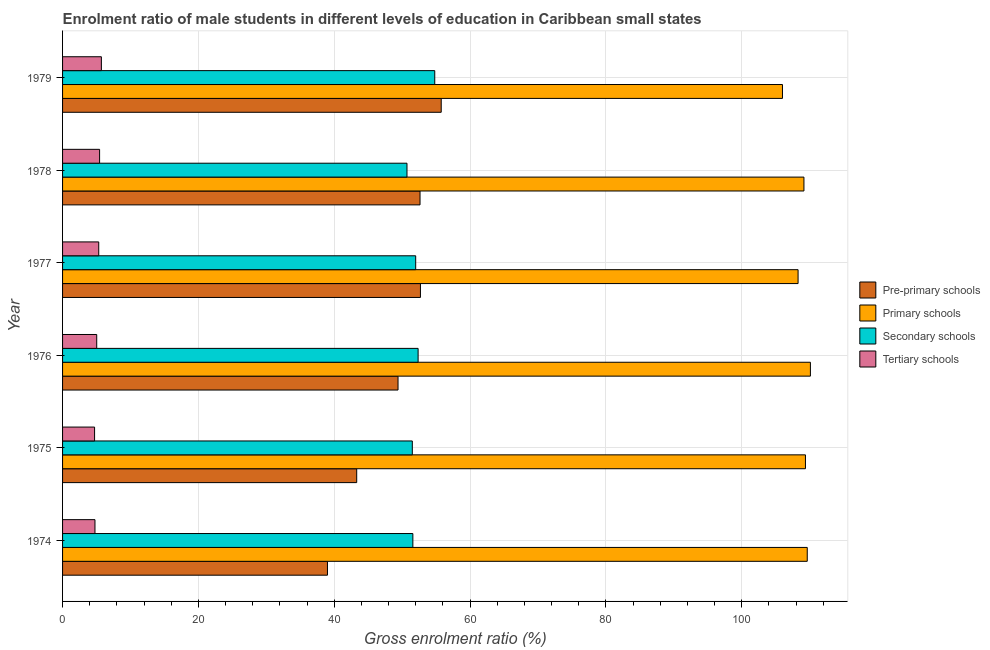What is the label of the 2nd group of bars from the top?
Your answer should be very brief. 1978. What is the gross enrolment ratio(female) in pre-primary schools in 1976?
Ensure brevity in your answer.  49.4. Across all years, what is the maximum gross enrolment ratio(female) in pre-primary schools?
Your answer should be very brief. 55.76. Across all years, what is the minimum gross enrolment ratio(female) in secondary schools?
Offer a terse response. 50.72. In which year was the gross enrolment ratio(female) in tertiary schools maximum?
Give a very brief answer. 1979. In which year was the gross enrolment ratio(female) in pre-primary schools minimum?
Provide a succinct answer. 1974. What is the total gross enrolment ratio(female) in primary schools in the graph?
Make the answer very short. 652.65. What is the difference between the gross enrolment ratio(female) in tertiary schools in 1975 and that in 1979?
Keep it short and to the point. -1. What is the difference between the gross enrolment ratio(female) in secondary schools in 1978 and the gross enrolment ratio(female) in pre-primary schools in 1976?
Your answer should be very brief. 1.32. What is the average gross enrolment ratio(female) in primary schools per year?
Provide a short and direct response. 108.78. In the year 1977, what is the difference between the gross enrolment ratio(female) in pre-primary schools and gross enrolment ratio(female) in primary schools?
Make the answer very short. -55.61. What is the ratio of the gross enrolment ratio(female) in tertiary schools in 1976 to that in 1979?
Provide a short and direct response. 0.88. What is the difference between the highest and the second highest gross enrolment ratio(female) in primary schools?
Your answer should be compact. 0.47. What is the difference between the highest and the lowest gross enrolment ratio(female) in primary schools?
Provide a succinct answer. 4.12. Is the sum of the gross enrolment ratio(female) in primary schools in 1976 and 1978 greater than the maximum gross enrolment ratio(female) in pre-primary schools across all years?
Offer a very short reply. Yes. Is it the case that in every year, the sum of the gross enrolment ratio(female) in tertiary schools and gross enrolment ratio(female) in secondary schools is greater than the sum of gross enrolment ratio(female) in pre-primary schools and gross enrolment ratio(female) in primary schools?
Provide a short and direct response. No. What does the 4th bar from the top in 1974 represents?
Make the answer very short. Pre-primary schools. What does the 2nd bar from the bottom in 1977 represents?
Your response must be concise. Primary schools. Is it the case that in every year, the sum of the gross enrolment ratio(female) in pre-primary schools and gross enrolment ratio(female) in primary schools is greater than the gross enrolment ratio(female) in secondary schools?
Give a very brief answer. Yes. Are all the bars in the graph horizontal?
Make the answer very short. Yes. How many years are there in the graph?
Offer a terse response. 6. What is the difference between two consecutive major ticks on the X-axis?
Offer a terse response. 20. Does the graph contain any zero values?
Make the answer very short. No. Does the graph contain grids?
Provide a short and direct response. Yes. Where does the legend appear in the graph?
Offer a very short reply. Center right. How are the legend labels stacked?
Your answer should be compact. Vertical. What is the title of the graph?
Keep it short and to the point. Enrolment ratio of male students in different levels of education in Caribbean small states. Does "Burnt food" appear as one of the legend labels in the graph?
Make the answer very short. No. What is the label or title of the Y-axis?
Your answer should be very brief. Year. What is the Gross enrolment ratio (%) in Pre-primary schools in 1974?
Your answer should be compact. 39.01. What is the Gross enrolment ratio (%) in Primary schools in 1974?
Provide a short and direct response. 109.66. What is the Gross enrolment ratio (%) of Secondary schools in 1974?
Give a very brief answer. 51.58. What is the Gross enrolment ratio (%) in Tertiary schools in 1974?
Offer a terse response. 4.77. What is the Gross enrolment ratio (%) of Pre-primary schools in 1975?
Give a very brief answer. 43.31. What is the Gross enrolment ratio (%) in Primary schools in 1975?
Provide a short and direct response. 109.39. What is the Gross enrolment ratio (%) in Secondary schools in 1975?
Your answer should be compact. 51.5. What is the Gross enrolment ratio (%) in Tertiary schools in 1975?
Provide a succinct answer. 4.71. What is the Gross enrolment ratio (%) of Pre-primary schools in 1976?
Ensure brevity in your answer.  49.4. What is the Gross enrolment ratio (%) of Primary schools in 1976?
Give a very brief answer. 110.12. What is the Gross enrolment ratio (%) of Secondary schools in 1976?
Your answer should be very brief. 52.35. What is the Gross enrolment ratio (%) of Tertiary schools in 1976?
Offer a very short reply. 5.03. What is the Gross enrolment ratio (%) of Pre-primary schools in 1977?
Offer a very short reply. 52.7. What is the Gross enrolment ratio (%) of Primary schools in 1977?
Ensure brevity in your answer.  108.31. What is the Gross enrolment ratio (%) of Secondary schools in 1977?
Your response must be concise. 52. What is the Gross enrolment ratio (%) in Tertiary schools in 1977?
Offer a terse response. 5.33. What is the Gross enrolment ratio (%) in Pre-primary schools in 1978?
Give a very brief answer. 52.64. What is the Gross enrolment ratio (%) of Primary schools in 1978?
Provide a short and direct response. 109.17. What is the Gross enrolment ratio (%) in Secondary schools in 1978?
Give a very brief answer. 50.72. What is the Gross enrolment ratio (%) of Tertiary schools in 1978?
Make the answer very short. 5.45. What is the Gross enrolment ratio (%) in Pre-primary schools in 1979?
Keep it short and to the point. 55.76. What is the Gross enrolment ratio (%) of Primary schools in 1979?
Offer a very short reply. 106.01. What is the Gross enrolment ratio (%) in Secondary schools in 1979?
Ensure brevity in your answer.  54.81. What is the Gross enrolment ratio (%) in Tertiary schools in 1979?
Offer a terse response. 5.71. Across all years, what is the maximum Gross enrolment ratio (%) in Pre-primary schools?
Offer a very short reply. 55.76. Across all years, what is the maximum Gross enrolment ratio (%) in Primary schools?
Your response must be concise. 110.12. Across all years, what is the maximum Gross enrolment ratio (%) in Secondary schools?
Your answer should be very brief. 54.81. Across all years, what is the maximum Gross enrolment ratio (%) in Tertiary schools?
Give a very brief answer. 5.71. Across all years, what is the minimum Gross enrolment ratio (%) in Pre-primary schools?
Provide a short and direct response. 39.01. Across all years, what is the minimum Gross enrolment ratio (%) in Primary schools?
Your response must be concise. 106.01. Across all years, what is the minimum Gross enrolment ratio (%) of Secondary schools?
Give a very brief answer. 50.72. Across all years, what is the minimum Gross enrolment ratio (%) of Tertiary schools?
Ensure brevity in your answer.  4.71. What is the total Gross enrolment ratio (%) of Pre-primary schools in the graph?
Provide a short and direct response. 292.81. What is the total Gross enrolment ratio (%) of Primary schools in the graph?
Give a very brief answer. 652.65. What is the total Gross enrolment ratio (%) in Secondary schools in the graph?
Give a very brief answer. 312.95. What is the total Gross enrolment ratio (%) in Tertiary schools in the graph?
Give a very brief answer. 31.01. What is the difference between the Gross enrolment ratio (%) of Pre-primary schools in 1974 and that in 1975?
Make the answer very short. -4.3. What is the difference between the Gross enrolment ratio (%) of Primary schools in 1974 and that in 1975?
Offer a very short reply. 0.27. What is the difference between the Gross enrolment ratio (%) of Tertiary schools in 1974 and that in 1975?
Provide a succinct answer. 0.06. What is the difference between the Gross enrolment ratio (%) of Pre-primary schools in 1974 and that in 1976?
Offer a terse response. -10.39. What is the difference between the Gross enrolment ratio (%) in Primary schools in 1974 and that in 1976?
Provide a short and direct response. -0.47. What is the difference between the Gross enrolment ratio (%) of Secondary schools in 1974 and that in 1976?
Keep it short and to the point. -0.77. What is the difference between the Gross enrolment ratio (%) of Tertiary schools in 1974 and that in 1976?
Your response must be concise. -0.26. What is the difference between the Gross enrolment ratio (%) of Pre-primary schools in 1974 and that in 1977?
Provide a succinct answer. -13.69. What is the difference between the Gross enrolment ratio (%) of Primary schools in 1974 and that in 1977?
Provide a short and direct response. 1.35. What is the difference between the Gross enrolment ratio (%) in Secondary schools in 1974 and that in 1977?
Your answer should be compact. -0.42. What is the difference between the Gross enrolment ratio (%) in Tertiary schools in 1974 and that in 1977?
Provide a short and direct response. -0.55. What is the difference between the Gross enrolment ratio (%) of Pre-primary schools in 1974 and that in 1978?
Keep it short and to the point. -13.63. What is the difference between the Gross enrolment ratio (%) in Primary schools in 1974 and that in 1978?
Your answer should be very brief. 0.49. What is the difference between the Gross enrolment ratio (%) of Secondary schools in 1974 and that in 1978?
Give a very brief answer. 0.86. What is the difference between the Gross enrolment ratio (%) in Tertiary schools in 1974 and that in 1978?
Make the answer very short. -0.68. What is the difference between the Gross enrolment ratio (%) in Pre-primary schools in 1974 and that in 1979?
Give a very brief answer. -16.75. What is the difference between the Gross enrolment ratio (%) of Primary schools in 1974 and that in 1979?
Your answer should be very brief. 3.65. What is the difference between the Gross enrolment ratio (%) of Secondary schools in 1974 and that in 1979?
Keep it short and to the point. -3.23. What is the difference between the Gross enrolment ratio (%) of Tertiary schools in 1974 and that in 1979?
Give a very brief answer. -0.94. What is the difference between the Gross enrolment ratio (%) in Pre-primary schools in 1975 and that in 1976?
Provide a short and direct response. -6.09. What is the difference between the Gross enrolment ratio (%) in Primary schools in 1975 and that in 1976?
Offer a terse response. -0.73. What is the difference between the Gross enrolment ratio (%) of Secondary schools in 1975 and that in 1976?
Provide a short and direct response. -0.85. What is the difference between the Gross enrolment ratio (%) of Tertiary schools in 1975 and that in 1976?
Offer a very short reply. -0.31. What is the difference between the Gross enrolment ratio (%) of Pre-primary schools in 1975 and that in 1977?
Offer a terse response. -9.38. What is the difference between the Gross enrolment ratio (%) in Primary schools in 1975 and that in 1977?
Your answer should be very brief. 1.08. What is the difference between the Gross enrolment ratio (%) of Secondary schools in 1975 and that in 1977?
Your answer should be compact. -0.5. What is the difference between the Gross enrolment ratio (%) in Tertiary schools in 1975 and that in 1977?
Keep it short and to the point. -0.61. What is the difference between the Gross enrolment ratio (%) in Pre-primary schools in 1975 and that in 1978?
Offer a very short reply. -9.33. What is the difference between the Gross enrolment ratio (%) in Primary schools in 1975 and that in 1978?
Keep it short and to the point. 0.22. What is the difference between the Gross enrolment ratio (%) in Secondary schools in 1975 and that in 1978?
Offer a very short reply. 0.78. What is the difference between the Gross enrolment ratio (%) in Tertiary schools in 1975 and that in 1978?
Provide a short and direct response. -0.74. What is the difference between the Gross enrolment ratio (%) in Pre-primary schools in 1975 and that in 1979?
Provide a succinct answer. -12.44. What is the difference between the Gross enrolment ratio (%) of Primary schools in 1975 and that in 1979?
Your answer should be very brief. 3.38. What is the difference between the Gross enrolment ratio (%) in Secondary schools in 1975 and that in 1979?
Your answer should be very brief. -3.31. What is the difference between the Gross enrolment ratio (%) in Tertiary schools in 1975 and that in 1979?
Provide a succinct answer. -1. What is the difference between the Gross enrolment ratio (%) in Pre-primary schools in 1976 and that in 1977?
Provide a short and direct response. -3.3. What is the difference between the Gross enrolment ratio (%) of Primary schools in 1976 and that in 1977?
Keep it short and to the point. 1.82. What is the difference between the Gross enrolment ratio (%) of Secondary schools in 1976 and that in 1977?
Provide a succinct answer. 0.36. What is the difference between the Gross enrolment ratio (%) of Tertiary schools in 1976 and that in 1977?
Provide a short and direct response. -0.3. What is the difference between the Gross enrolment ratio (%) in Pre-primary schools in 1976 and that in 1978?
Your answer should be compact. -3.24. What is the difference between the Gross enrolment ratio (%) of Primary schools in 1976 and that in 1978?
Your answer should be very brief. 0.95. What is the difference between the Gross enrolment ratio (%) in Secondary schools in 1976 and that in 1978?
Your answer should be very brief. 1.64. What is the difference between the Gross enrolment ratio (%) in Tertiary schools in 1976 and that in 1978?
Keep it short and to the point. -0.42. What is the difference between the Gross enrolment ratio (%) in Pre-primary schools in 1976 and that in 1979?
Offer a terse response. -6.36. What is the difference between the Gross enrolment ratio (%) in Primary schools in 1976 and that in 1979?
Offer a very short reply. 4.12. What is the difference between the Gross enrolment ratio (%) of Secondary schools in 1976 and that in 1979?
Provide a succinct answer. -2.45. What is the difference between the Gross enrolment ratio (%) of Tertiary schools in 1976 and that in 1979?
Make the answer very short. -0.69. What is the difference between the Gross enrolment ratio (%) of Pre-primary schools in 1977 and that in 1978?
Your answer should be very brief. 0.06. What is the difference between the Gross enrolment ratio (%) of Primary schools in 1977 and that in 1978?
Offer a very short reply. -0.86. What is the difference between the Gross enrolment ratio (%) in Secondary schools in 1977 and that in 1978?
Keep it short and to the point. 1.28. What is the difference between the Gross enrolment ratio (%) in Tertiary schools in 1977 and that in 1978?
Ensure brevity in your answer.  -0.13. What is the difference between the Gross enrolment ratio (%) in Pre-primary schools in 1977 and that in 1979?
Offer a very short reply. -3.06. What is the difference between the Gross enrolment ratio (%) of Primary schools in 1977 and that in 1979?
Give a very brief answer. 2.3. What is the difference between the Gross enrolment ratio (%) in Secondary schools in 1977 and that in 1979?
Offer a very short reply. -2.81. What is the difference between the Gross enrolment ratio (%) of Tertiary schools in 1977 and that in 1979?
Provide a succinct answer. -0.39. What is the difference between the Gross enrolment ratio (%) in Pre-primary schools in 1978 and that in 1979?
Give a very brief answer. -3.12. What is the difference between the Gross enrolment ratio (%) in Primary schools in 1978 and that in 1979?
Keep it short and to the point. 3.16. What is the difference between the Gross enrolment ratio (%) in Secondary schools in 1978 and that in 1979?
Your answer should be very brief. -4.09. What is the difference between the Gross enrolment ratio (%) in Tertiary schools in 1978 and that in 1979?
Provide a succinct answer. -0.26. What is the difference between the Gross enrolment ratio (%) in Pre-primary schools in 1974 and the Gross enrolment ratio (%) in Primary schools in 1975?
Provide a succinct answer. -70.38. What is the difference between the Gross enrolment ratio (%) in Pre-primary schools in 1974 and the Gross enrolment ratio (%) in Secondary schools in 1975?
Make the answer very short. -12.49. What is the difference between the Gross enrolment ratio (%) in Pre-primary schools in 1974 and the Gross enrolment ratio (%) in Tertiary schools in 1975?
Make the answer very short. 34.29. What is the difference between the Gross enrolment ratio (%) of Primary schools in 1974 and the Gross enrolment ratio (%) of Secondary schools in 1975?
Your answer should be compact. 58.16. What is the difference between the Gross enrolment ratio (%) of Primary schools in 1974 and the Gross enrolment ratio (%) of Tertiary schools in 1975?
Provide a succinct answer. 104.94. What is the difference between the Gross enrolment ratio (%) of Secondary schools in 1974 and the Gross enrolment ratio (%) of Tertiary schools in 1975?
Provide a short and direct response. 46.87. What is the difference between the Gross enrolment ratio (%) in Pre-primary schools in 1974 and the Gross enrolment ratio (%) in Primary schools in 1976?
Make the answer very short. -71.11. What is the difference between the Gross enrolment ratio (%) in Pre-primary schools in 1974 and the Gross enrolment ratio (%) in Secondary schools in 1976?
Provide a succinct answer. -13.35. What is the difference between the Gross enrolment ratio (%) in Pre-primary schools in 1974 and the Gross enrolment ratio (%) in Tertiary schools in 1976?
Give a very brief answer. 33.98. What is the difference between the Gross enrolment ratio (%) of Primary schools in 1974 and the Gross enrolment ratio (%) of Secondary schools in 1976?
Provide a succinct answer. 57.3. What is the difference between the Gross enrolment ratio (%) in Primary schools in 1974 and the Gross enrolment ratio (%) in Tertiary schools in 1976?
Ensure brevity in your answer.  104.63. What is the difference between the Gross enrolment ratio (%) in Secondary schools in 1974 and the Gross enrolment ratio (%) in Tertiary schools in 1976?
Provide a succinct answer. 46.55. What is the difference between the Gross enrolment ratio (%) of Pre-primary schools in 1974 and the Gross enrolment ratio (%) of Primary schools in 1977?
Your answer should be compact. -69.3. What is the difference between the Gross enrolment ratio (%) in Pre-primary schools in 1974 and the Gross enrolment ratio (%) in Secondary schools in 1977?
Provide a succinct answer. -12.99. What is the difference between the Gross enrolment ratio (%) of Pre-primary schools in 1974 and the Gross enrolment ratio (%) of Tertiary schools in 1977?
Your response must be concise. 33.68. What is the difference between the Gross enrolment ratio (%) of Primary schools in 1974 and the Gross enrolment ratio (%) of Secondary schools in 1977?
Make the answer very short. 57.66. What is the difference between the Gross enrolment ratio (%) in Primary schools in 1974 and the Gross enrolment ratio (%) in Tertiary schools in 1977?
Provide a short and direct response. 104.33. What is the difference between the Gross enrolment ratio (%) of Secondary schools in 1974 and the Gross enrolment ratio (%) of Tertiary schools in 1977?
Give a very brief answer. 46.25. What is the difference between the Gross enrolment ratio (%) in Pre-primary schools in 1974 and the Gross enrolment ratio (%) in Primary schools in 1978?
Your answer should be compact. -70.16. What is the difference between the Gross enrolment ratio (%) of Pre-primary schools in 1974 and the Gross enrolment ratio (%) of Secondary schools in 1978?
Provide a succinct answer. -11.71. What is the difference between the Gross enrolment ratio (%) of Pre-primary schools in 1974 and the Gross enrolment ratio (%) of Tertiary schools in 1978?
Your response must be concise. 33.55. What is the difference between the Gross enrolment ratio (%) of Primary schools in 1974 and the Gross enrolment ratio (%) of Secondary schools in 1978?
Ensure brevity in your answer.  58.94. What is the difference between the Gross enrolment ratio (%) in Primary schools in 1974 and the Gross enrolment ratio (%) in Tertiary schools in 1978?
Your answer should be very brief. 104.2. What is the difference between the Gross enrolment ratio (%) in Secondary schools in 1974 and the Gross enrolment ratio (%) in Tertiary schools in 1978?
Provide a succinct answer. 46.13. What is the difference between the Gross enrolment ratio (%) of Pre-primary schools in 1974 and the Gross enrolment ratio (%) of Primary schools in 1979?
Offer a very short reply. -67. What is the difference between the Gross enrolment ratio (%) in Pre-primary schools in 1974 and the Gross enrolment ratio (%) in Secondary schools in 1979?
Keep it short and to the point. -15.8. What is the difference between the Gross enrolment ratio (%) in Pre-primary schools in 1974 and the Gross enrolment ratio (%) in Tertiary schools in 1979?
Make the answer very short. 33.29. What is the difference between the Gross enrolment ratio (%) in Primary schools in 1974 and the Gross enrolment ratio (%) in Secondary schools in 1979?
Your response must be concise. 54.85. What is the difference between the Gross enrolment ratio (%) in Primary schools in 1974 and the Gross enrolment ratio (%) in Tertiary schools in 1979?
Make the answer very short. 103.94. What is the difference between the Gross enrolment ratio (%) of Secondary schools in 1974 and the Gross enrolment ratio (%) of Tertiary schools in 1979?
Offer a terse response. 45.87. What is the difference between the Gross enrolment ratio (%) in Pre-primary schools in 1975 and the Gross enrolment ratio (%) in Primary schools in 1976?
Ensure brevity in your answer.  -66.81. What is the difference between the Gross enrolment ratio (%) of Pre-primary schools in 1975 and the Gross enrolment ratio (%) of Secondary schools in 1976?
Give a very brief answer. -9.04. What is the difference between the Gross enrolment ratio (%) of Pre-primary schools in 1975 and the Gross enrolment ratio (%) of Tertiary schools in 1976?
Provide a short and direct response. 38.28. What is the difference between the Gross enrolment ratio (%) of Primary schools in 1975 and the Gross enrolment ratio (%) of Secondary schools in 1976?
Offer a very short reply. 57.04. What is the difference between the Gross enrolment ratio (%) of Primary schools in 1975 and the Gross enrolment ratio (%) of Tertiary schools in 1976?
Make the answer very short. 104.36. What is the difference between the Gross enrolment ratio (%) in Secondary schools in 1975 and the Gross enrolment ratio (%) in Tertiary schools in 1976?
Provide a short and direct response. 46.47. What is the difference between the Gross enrolment ratio (%) in Pre-primary schools in 1975 and the Gross enrolment ratio (%) in Primary schools in 1977?
Make the answer very short. -64.99. What is the difference between the Gross enrolment ratio (%) in Pre-primary schools in 1975 and the Gross enrolment ratio (%) in Secondary schools in 1977?
Offer a terse response. -8.69. What is the difference between the Gross enrolment ratio (%) in Pre-primary schools in 1975 and the Gross enrolment ratio (%) in Tertiary schools in 1977?
Make the answer very short. 37.99. What is the difference between the Gross enrolment ratio (%) in Primary schools in 1975 and the Gross enrolment ratio (%) in Secondary schools in 1977?
Provide a succinct answer. 57.39. What is the difference between the Gross enrolment ratio (%) in Primary schools in 1975 and the Gross enrolment ratio (%) in Tertiary schools in 1977?
Keep it short and to the point. 104.06. What is the difference between the Gross enrolment ratio (%) in Secondary schools in 1975 and the Gross enrolment ratio (%) in Tertiary schools in 1977?
Provide a short and direct response. 46.17. What is the difference between the Gross enrolment ratio (%) of Pre-primary schools in 1975 and the Gross enrolment ratio (%) of Primary schools in 1978?
Your answer should be compact. -65.86. What is the difference between the Gross enrolment ratio (%) of Pre-primary schools in 1975 and the Gross enrolment ratio (%) of Secondary schools in 1978?
Your answer should be very brief. -7.4. What is the difference between the Gross enrolment ratio (%) of Pre-primary schools in 1975 and the Gross enrolment ratio (%) of Tertiary schools in 1978?
Give a very brief answer. 37.86. What is the difference between the Gross enrolment ratio (%) of Primary schools in 1975 and the Gross enrolment ratio (%) of Secondary schools in 1978?
Offer a terse response. 58.68. What is the difference between the Gross enrolment ratio (%) in Primary schools in 1975 and the Gross enrolment ratio (%) in Tertiary schools in 1978?
Provide a short and direct response. 103.94. What is the difference between the Gross enrolment ratio (%) of Secondary schools in 1975 and the Gross enrolment ratio (%) of Tertiary schools in 1978?
Offer a terse response. 46.05. What is the difference between the Gross enrolment ratio (%) in Pre-primary schools in 1975 and the Gross enrolment ratio (%) in Primary schools in 1979?
Your answer should be very brief. -62.69. What is the difference between the Gross enrolment ratio (%) in Pre-primary schools in 1975 and the Gross enrolment ratio (%) in Secondary schools in 1979?
Provide a succinct answer. -11.49. What is the difference between the Gross enrolment ratio (%) in Pre-primary schools in 1975 and the Gross enrolment ratio (%) in Tertiary schools in 1979?
Provide a succinct answer. 37.6. What is the difference between the Gross enrolment ratio (%) in Primary schools in 1975 and the Gross enrolment ratio (%) in Secondary schools in 1979?
Keep it short and to the point. 54.59. What is the difference between the Gross enrolment ratio (%) in Primary schools in 1975 and the Gross enrolment ratio (%) in Tertiary schools in 1979?
Offer a very short reply. 103.68. What is the difference between the Gross enrolment ratio (%) in Secondary schools in 1975 and the Gross enrolment ratio (%) in Tertiary schools in 1979?
Offer a terse response. 45.79. What is the difference between the Gross enrolment ratio (%) of Pre-primary schools in 1976 and the Gross enrolment ratio (%) of Primary schools in 1977?
Provide a succinct answer. -58.91. What is the difference between the Gross enrolment ratio (%) in Pre-primary schools in 1976 and the Gross enrolment ratio (%) in Secondary schools in 1977?
Offer a very short reply. -2.6. What is the difference between the Gross enrolment ratio (%) in Pre-primary schools in 1976 and the Gross enrolment ratio (%) in Tertiary schools in 1977?
Keep it short and to the point. 44.07. What is the difference between the Gross enrolment ratio (%) in Primary schools in 1976 and the Gross enrolment ratio (%) in Secondary schools in 1977?
Your response must be concise. 58.12. What is the difference between the Gross enrolment ratio (%) of Primary schools in 1976 and the Gross enrolment ratio (%) of Tertiary schools in 1977?
Ensure brevity in your answer.  104.8. What is the difference between the Gross enrolment ratio (%) in Secondary schools in 1976 and the Gross enrolment ratio (%) in Tertiary schools in 1977?
Offer a terse response. 47.03. What is the difference between the Gross enrolment ratio (%) of Pre-primary schools in 1976 and the Gross enrolment ratio (%) of Primary schools in 1978?
Offer a very short reply. -59.77. What is the difference between the Gross enrolment ratio (%) of Pre-primary schools in 1976 and the Gross enrolment ratio (%) of Secondary schools in 1978?
Offer a very short reply. -1.32. What is the difference between the Gross enrolment ratio (%) in Pre-primary schools in 1976 and the Gross enrolment ratio (%) in Tertiary schools in 1978?
Keep it short and to the point. 43.94. What is the difference between the Gross enrolment ratio (%) of Primary schools in 1976 and the Gross enrolment ratio (%) of Secondary schools in 1978?
Your response must be concise. 59.41. What is the difference between the Gross enrolment ratio (%) of Primary schools in 1976 and the Gross enrolment ratio (%) of Tertiary schools in 1978?
Ensure brevity in your answer.  104.67. What is the difference between the Gross enrolment ratio (%) in Secondary schools in 1976 and the Gross enrolment ratio (%) in Tertiary schools in 1978?
Your response must be concise. 46.9. What is the difference between the Gross enrolment ratio (%) of Pre-primary schools in 1976 and the Gross enrolment ratio (%) of Primary schools in 1979?
Provide a succinct answer. -56.61. What is the difference between the Gross enrolment ratio (%) of Pre-primary schools in 1976 and the Gross enrolment ratio (%) of Secondary schools in 1979?
Ensure brevity in your answer.  -5.41. What is the difference between the Gross enrolment ratio (%) of Pre-primary schools in 1976 and the Gross enrolment ratio (%) of Tertiary schools in 1979?
Your answer should be very brief. 43.68. What is the difference between the Gross enrolment ratio (%) in Primary schools in 1976 and the Gross enrolment ratio (%) in Secondary schools in 1979?
Make the answer very short. 55.32. What is the difference between the Gross enrolment ratio (%) of Primary schools in 1976 and the Gross enrolment ratio (%) of Tertiary schools in 1979?
Your answer should be compact. 104.41. What is the difference between the Gross enrolment ratio (%) of Secondary schools in 1976 and the Gross enrolment ratio (%) of Tertiary schools in 1979?
Provide a succinct answer. 46.64. What is the difference between the Gross enrolment ratio (%) of Pre-primary schools in 1977 and the Gross enrolment ratio (%) of Primary schools in 1978?
Your answer should be very brief. -56.47. What is the difference between the Gross enrolment ratio (%) of Pre-primary schools in 1977 and the Gross enrolment ratio (%) of Secondary schools in 1978?
Make the answer very short. 1.98. What is the difference between the Gross enrolment ratio (%) in Pre-primary schools in 1977 and the Gross enrolment ratio (%) in Tertiary schools in 1978?
Offer a terse response. 47.24. What is the difference between the Gross enrolment ratio (%) of Primary schools in 1977 and the Gross enrolment ratio (%) of Secondary schools in 1978?
Give a very brief answer. 57.59. What is the difference between the Gross enrolment ratio (%) of Primary schools in 1977 and the Gross enrolment ratio (%) of Tertiary schools in 1978?
Offer a very short reply. 102.85. What is the difference between the Gross enrolment ratio (%) of Secondary schools in 1977 and the Gross enrolment ratio (%) of Tertiary schools in 1978?
Your answer should be very brief. 46.54. What is the difference between the Gross enrolment ratio (%) in Pre-primary schools in 1977 and the Gross enrolment ratio (%) in Primary schools in 1979?
Provide a succinct answer. -53.31. What is the difference between the Gross enrolment ratio (%) in Pre-primary schools in 1977 and the Gross enrolment ratio (%) in Secondary schools in 1979?
Your answer should be very brief. -2.11. What is the difference between the Gross enrolment ratio (%) of Pre-primary schools in 1977 and the Gross enrolment ratio (%) of Tertiary schools in 1979?
Your response must be concise. 46.98. What is the difference between the Gross enrolment ratio (%) in Primary schools in 1977 and the Gross enrolment ratio (%) in Secondary schools in 1979?
Provide a succinct answer. 53.5. What is the difference between the Gross enrolment ratio (%) of Primary schools in 1977 and the Gross enrolment ratio (%) of Tertiary schools in 1979?
Provide a succinct answer. 102.59. What is the difference between the Gross enrolment ratio (%) of Secondary schools in 1977 and the Gross enrolment ratio (%) of Tertiary schools in 1979?
Provide a succinct answer. 46.28. What is the difference between the Gross enrolment ratio (%) in Pre-primary schools in 1978 and the Gross enrolment ratio (%) in Primary schools in 1979?
Your response must be concise. -53.37. What is the difference between the Gross enrolment ratio (%) of Pre-primary schools in 1978 and the Gross enrolment ratio (%) of Secondary schools in 1979?
Your answer should be very brief. -2.17. What is the difference between the Gross enrolment ratio (%) of Pre-primary schools in 1978 and the Gross enrolment ratio (%) of Tertiary schools in 1979?
Give a very brief answer. 46.92. What is the difference between the Gross enrolment ratio (%) in Primary schools in 1978 and the Gross enrolment ratio (%) in Secondary schools in 1979?
Offer a terse response. 54.36. What is the difference between the Gross enrolment ratio (%) in Primary schools in 1978 and the Gross enrolment ratio (%) in Tertiary schools in 1979?
Your answer should be very brief. 103.46. What is the difference between the Gross enrolment ratio (%) in Secondary schools in 1978 and the Gross enrolment ratio (%) in Tertiary schools in 1979?
Offer a very short reply. 45. What is the average Gross enrolment ratio (%) of Pre-primary schools per year?
Give a very brief answer. 48.8. What is the average Gross enrolment ratio (%) in Primary schools per year?
Make the answer very short. 108.78. What is the average Gross enrolment ratio (%) in Secondary schools per year?
Your answer should be very brief. 52.16. What is the average Gross enrolment ratio (%) of Tertiary schools per year?
Provide a succinct answer. 5.17. In the year 1974, what is the difference between the Gross enrolment ratio (%) of Pre-primary schools and Gross enrolment ratio (%) of Primary schools?
Your response must be concise. -70.65. In the year 1974, what is the difference between the Gross enrolment ratio (%) in Pre-primary schools and Gross enrolment ratio (%) in Secondary schools?
Provide a succinct answer. -12.57. In the year 1974, what is the difference between the Gross enrolment ratio (%) in Pre-primary schools and Gross enrolment ratio (%) in Tertiary schools?
Your response must be concise. 34.24. In the year 1974, what is the difference between the Gross enrolment ratio (%) in Primary schools and Gross enrolment ratio (%) in Secondary schools?
Provide a short and direct response. 58.08. In the year 1974, what is the difference between the Gross enrolment ratio (%) of Primary schools and Gross enrolment ratio (%) of Tertiary schools?
Make the answer very short. 104.88. In the year 1974, what is the difference between the Gross enrolment ratio (%) of Secondary schools and Gross enrolment ratio (%) of Tertiary schools?
Ensure brevity in your answer.  46.81. In the year 1975, what is the difference between the Gross enrolment ratio (%) of Pre-primary schools and Gross enrolment ratio (%) of Primary schools?
Offer a very short reply. -66.08. In the year 1975, what is the difference between the Gross enrolment ratio (%) in Pre-primary schools and Gross enrolment ratio (%) in Secondary schools?
Keep it short and to the point. -8.19. In the year 1975, what is the difference between the Gross enrolment ratio (%) in Pre-primary schools and Gross enrolment ratio (%) in Tertiary schools?
Your answer should be very brief. 38.6. In the year 1975, what is the difference between the Gross enrolment ratio (%) of Primary schools and Gross enrolment ratio (%) of Secondary schools?
Make the answer very short. 57.89. In the year 1975, what is the difference between the Gross enrolment ratio (%) of Primary schools and Gross enrolment ratio (%) of Tertiary schools?
Your answer should be compact. 104.68. In the year 1975, what is the difference between the Gross enrolment ratio (%) in Secondary schools and Gross enrolment ratio (%) in Tertiary schools?
Your answer should be compact. 46.79. In the year 1976, what is the difference between the Gross enrolment ratio (%) of Pre-primary schools and Gross enrolment ratio (%) of Primary schools?
Give a very brief answer. -60.72. In the year 1976, what is the difference between the Gross enrolment ratio (%) in Pre-primary schools and Gross enrolment ratio (%) in Secondary schools?
Provide a succinct answer. -2.96. In the year 1976, what is the difference between the Gross enrolment ratio (%) in Pre-primary schools and Gross enrolment ratio (%) in Tertiary schools?
Your answer should be very brief. 44.37. In the year 1976, what is the difference between the Gross enrolment ratio (%) in Primary schools and Gross enrolment ratio (%) in Secondary schools?
Your response must be concise. 57.77. In the year 1976, what is the difference between the Gross enrolment ratio (%) of Primary schools and Gross enrolment ratio (%) of Tertiary schools?
Offer a very short reply. 105.09. In the year 1976, what is the difference between the Gross enrolment ratio (%) of Secondary schools and Gross enrolment ratio (%) of Tertiary schools?
Provide a succinct answer. 47.33. In the year 1977, what is the difference between the Gross enrolment ratio (%) in Pre-primary schools and Gross enrolment ratio (%) in Primary schools?
Provide a succinct answer. -55.61. In the year 1977, what is the difference between the Gross enrolment ratio (%) of Pre-primary schools and Gross enrolment ratio (%) of Secondary schools?
Your answer should be compact. 0.7. In the year 1977, what is the difference between the Gross enrolment ratio (%) in Pre-primary schools and Gross enrolment ratio (%) in Tertiary schools?
Your answer should be very brief. 47.37. In the year 1977, what is the difference between the Gross enrolment ratio (%) in Primary schools and Gross enrolment ratio (%) in Secondary schools?
Offer a very short reply. 56.31. In the year 1977, what is the difference between the Gross enrolment ratio (%) in Primary schools and Gross enrolment ratio (%) in Tertiary schools?
Provide a short and direct response. 102.98. In the year 1977, what is the difference between the Gross enrolment ratio (%) in Secondary schools and Gross enrolment ratio (%) in Tertiary schools?
Offer a terse response. 46.67. In the year 1978, what is the difference between the Gross enrolment ratio (%) in Pre-primary schools and Gross enrolment ratio (%) in Primary schools?
Offer a terse response. -56.53. In the year 1978, what is the difference between the Gross enrolment ratio (%) in Pre-primary schools and Gross enrolment ratio (%) in Secondary schools?
Make the answer very short. 1.92. In the year 1978, what is the difference between the Gross enrolment ratio (%) in Pre-primary schools and Gross enrolment ratio (%) in Tertiary schools?
Offer a very short reply. 47.18. In the year 1978, what is the difference between the Gross enrolment ratio (%) in Primary schools and Gross enrolment ratio (%) in Secondary schools?
Your answer should be very brief. 58.45. In the year 1978, what is the difference between the Gross enrolment ratio (%) of Primary schools and Gross enrolment ratio (%) of Tertiary schools?
Your answer should be very brief. 103.72. In the year 1978, what is the difference between the Gross enrolment ratio (%) of Secondary schools and Gross enrolment ratio (%) of Tertiary schools?
Make the answer very short. 45.26. In the year 1979, what is the difference between the Gross enrolment ratio (%) of Pre-primary schools and Gross enrolment ratio (%) of Primary schools?
Your answer should be compact. -50.25. In the year 1979, what is the difference between the Gross enrolment ratio (%) of Pre-primary schools and Gross enrolment ratio (%) of Secondary schools?
Ensure brevity in your answer.  0.95. In the year 1979, what is the difference between the Gross enrolment ratio (%) of Pre-primary schools and Gross enrolment ratio (%) of Tertiary schools?
Your response must be concise. 50.04. In the year 1979, what is the difference between the Gross enrolment ratio (%) of Primary schools and Gross enrolment ratio (%) of Secondary schools?
Your response must be concise. 51.2. In the year 1979, what is the difference between the Gross enrolment ratio (%) in Primary schools and Gross enrolment ratio (%) in Tertiary schools?
Offer a terse response. 100.29. In the year 1979, what is the difference between the Gross enrolment ratio (%) in Secondary schools and Gross enrolment ratio (%) in Tertiary schools?
Provide a short and direct response. 49.09. What is the ratio of the Gross enrolment ratio (%) of Pre-primary schools in 1974 to that in 1975?
Make the answer very short. 0.9. What is the ratio of the Gross enrolment ratio (%) in Primary schools in 1974 to that in 1975?
Give a very brief answer. 1. What is the ratio of the Gross enrolment ratio (%) in Tertiary schools in 1974 to that in 1975?
Give a very brief answer. 1.01. What is the ratio of the Gross enrolment ratio (%) in Pre-primary schools in 1974 to that in 1976?
Offer a terse response. 0.79. What is the ratio of the Gross enrolment ratio (%) of Secondary schools in 1974 to that in 1976?
Keep it short and to the point. 0.99. What is the ratio of the Gross enrolment ratio (%) in Tertiary schools in 1974 to that in 1976?
Provide a short and direct response. 0.95. What is the ratio of the Gross enrolment ratio (%) in Pre-primary schools in 1974 to that in 1977?
Provide a short and direct response. 0.74. What is the ratio of the Gross enrolment ratio (%) of Primary schools in 1974 to that in 1977?
Your answer should be compact. 1.01. What is the ratio of the Gross enrolment ratio (%) in Secondary schools in 1974 to that in 1977?
Offer a very short reply. 0.99. What is the ratio of the Gross enrolment ratio (%) of Tertiary schools in 1974 to that in 1977?
Your answer should be compact. 0.9. What is the ratio of the Gross enrolment ratio (%) in Pre-primary schools in 1974 to that in 1978?
Provide a short and direct response. 0.74. What is the ratio of the Gross enrolment ratio (%) in Primary schools in 1974 to that in 1978?
Offer a terse response. 1. What is the ratio of the Gross enrolment ratio (%) of Tertiary schools in 1974 to that in 1978?
Ensure brevity in your answer.  0.88. What is the ratio of the Gross enrolment ratio (%) in Pre-primary schools in 1974 to that in 1979?
Give a very brief answer. 0.7. What is the ratio of the Gross enrolment ratio (%) of Primary schools in 1974 to that in 1979?
Your answer should be compact. 1.03. What is the ratio of the Gross enrolment ratio (%) of Tertiary schools in 1974 to that in 1979?
Your answer should be compact. 0.84. What is the ratio of the Gross enrolment ratio (%) in Pre-primary schools in 1975 to that in 1976?
Your answer should be compact. 0.88. What is the ratio of the Gross enrolment ratio (%) of Secondary schools in 1975 to that in 1976?
Give a very brief answer. 0.98. What is the ratio of the Gross enrolment ratio (%) of Tertiary schools in 1975 to that in 1976?
Offer a terse response. 0.94. What is the ratio of the Gross enrolment ratio (%) in Pre-primary schools in 1975 to that in 1977?
Your response must be concise. 0.82. What is the ratio of the Gross enrolment ratio (%) in Primary schools in 1975 to that in 1977?
Provide a succinct answer. 1.01. What is the ratio of the Gross enrolment ratio (%) in Secondary schools in 1975 to that in 1977?
Provide a short and direct response. 0.99. What is the ratio of the Gross enrolment ratio (%) in Tertiary schools in 1975 to that in 1977?
Keep it short and to the point. 0.89. What is the ratio of the Gross enrolment ratio (%) of Pre-primary schools in 1975 to that in 1978?
Make the answer very short. 0.82. What is the ratio of the Gross enrolment ratio (%) of Primary schools in 1975 to that in 1978?
Make the answer very short. 1. What is the ratio of the Gross enrolment ratio (%) of Secondary schools in 1975 to that in 1978?
Provide a succinct answer. 1.02. What is the ratio of the Gross enrolment ratio (%) of Tertiary schools in 1975 to that in 1978?
Provide a succinct answer. 0.86. What is the ratio of the Gross enrolment ratio (%) of Pre-primary schools in 1975 to that in 1979?
Your answer should be very brief. 0.78. What is the ratio of the Gross enrolment ratio (%) of Primary schools in 1975 to that in 1979?
Offer a very short reply. 1.03. What is the ratio of the Gross enrolment ratio (%) in Secondary schools in 1975 to that in 1979?
Provide a short and direct response. 0.94. What is the ratio of the Gross enrolment ratio (%) in Tertiary schools in 1975 to that in 1979?
Provide a short and direct response. 0.82. What is the ratio of the Gross enrolment ratio (%) of Pre-primary schools in 1976 to that in 1977?
Give a very brief answer. 0.94. What is the ratio of the Gross enrolment ratio (%) of Primary schools in 1976 to that in 1977?
Provide a short and direct response. 1.02. What is the ratio of the Gross enrolment ratio (%) of Tertiary schools in 1976 to that in 1977?
Keep it short and to the point. 0.94. What is the ratio of the Gross enrolment ratio (%) of Pre-primary schools in 1976 to that in 1978?
Offer a very short reply. 0.94. What is the ratio of the Gross enrolment ratio (%) of Primary schools in 1976 to that in 1978?
Provide a succinct answer. 1.01. What is the ratio of the Gross enrolment ratio (%) of Secondary schools in 1976 to that in 1978?
Make the answer very short. 1.03. What is the ratio of the Gross enrolment ratio (%) in Tertiary schools in 1976 to that in 1978?
Provide a succinct answer. 0.92. What is the ratio of the Gross enrolment ratio (%) in Pre-primary schools in 1976 to that in 1979?
Your answer should be compact. 0.89. What is the ratio of the Gross enrolment ratio (%) in Primary schools in 1976 to that in 1979?
Provide a succinct answer. 1.04. What is the ratio of the Gross enrolment ratio (%) in Secondary schools in 1976 to that in 1979?
Your answer should be compact. 0.96. What is the ratio of the Gross enrolment ratio (%) of Tertiary schools in 1976 to that in 1979?
Make the answer very short. 0.88. What is the ratio of the Gross enrolment ratio (%) of Primary schools in 1977 to that in 1978?
Your response must be concise. 0.99. What is the ratio of the Gross enrolment ratio (%) in Secondary schools in 1977 to that in 1978?
Offer a terse response. 1.03. What is the ratio of the Gross enrolment ratio (%) of Tertiary schools in 1977 to that in 1978?
Make the answer very short. 0.98. What is the ratio of the Gross enrolment ratio (%) in Pre-primary schools in 1977 to that in 1979?
Ensure brevity in your answer.  0.95. What is the ratio of the Gross enrolment ratio (%) in Primary schools in 1977 to that in 1979?
Make the answer very short. 1.02. What is the ratio of the Gross enrolment ratio (%) in Secondary schools in 1977 to that in 1979?
Make the answer very short. 0.95. What is the ratio of the Gross enrolment ratio (%) in Tertiary schools in 1977 to that in 1979?
Keep it short and to the point. 0.93. What is the ratio of the Gross enrolment ratio (%) of Pre-primary schools in 1978 to that in 1979?
Your answer should be compact. 0.94. What is the ratio of the Gross enrolment ratio (%) in Primary schools in 1978 to that in 1979?
Provide a short and direct response. 1.03. What is the ratio of the Gross enrolment ratio (%) of Secondary schools in 1978 to that in 1979?
Make the answer very short. 0.93. What is the ratio of the Gross enrolment ratio (%) in Tertiary schools in 1978 to that in 1979?
Make the answer very short. 0.95. What is the difference between the highest and the second highest Gross enrolment ratio (%) in Pre-primary schools?
Offer a very short reply. 3.06. What is the difference between the highest and the second highest Gross enrolment ratio (%) of Primary schools?
Your response must be concise. 0.47. What is the difference between the highest and the second highest Gross enrolment ratio (%) in Secondary schools?
Make the answer very short. 2.45. What is the difference between the highest and the second highest Gross enrolment ratio (%) in Tertiary schools?
Provide a succinct answer. 0.26. What is the difference between the highest and the lowest Gross enrolment ratio (%) of Pre-primary schools?
Make the answer very short. 16.75. What is the difference between the highest and the lowest Gross enrolment ratio (%) in Primary schools?
Offer a terse response. 4.12. What is the difference between the highest and the lowest Gross enrolment ratio (%) in Secondary schools?
Offer a terse response. 4.09. What is the difference between the highest and the lowest Gross enrolment ratio (%) of Tertiary schools?
Give a very brief answer. 1. 